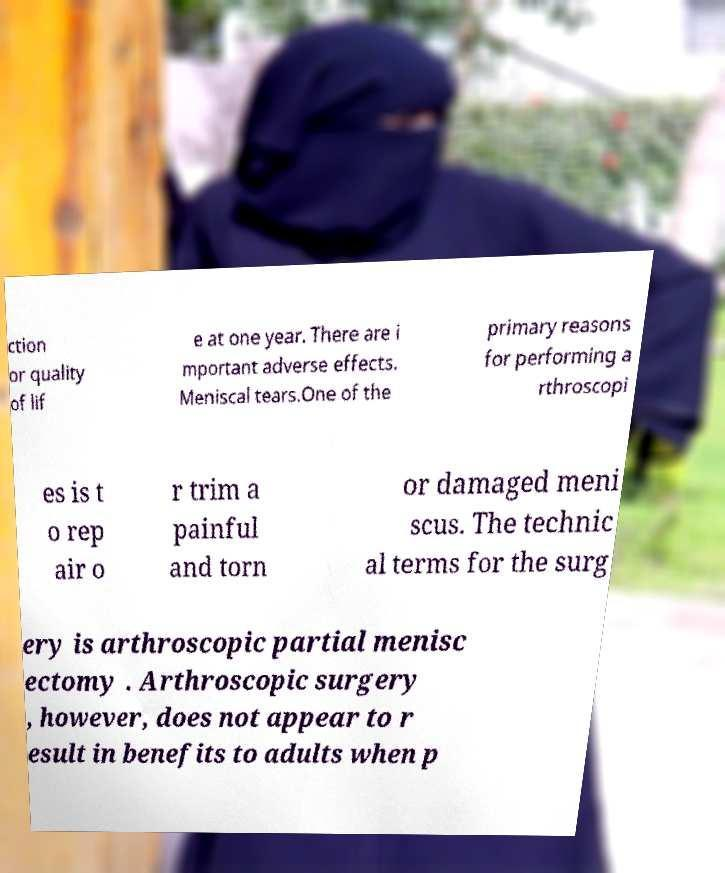Could you assist in decoding the text presented in this image and type it out clearly? ction or quality of lif e at one year. There are i mportant adverse effects. Meniscal tears.One of the primary reasons for performing a rthroscopi es is t o rep air o r trim a painful and torn or damaged meni scus. The technic al terms for the surg ery is arthroscopic partial menisc ectomy . Arthroscopic surgery , however, does not appear to r esult in benefits to adults when p 